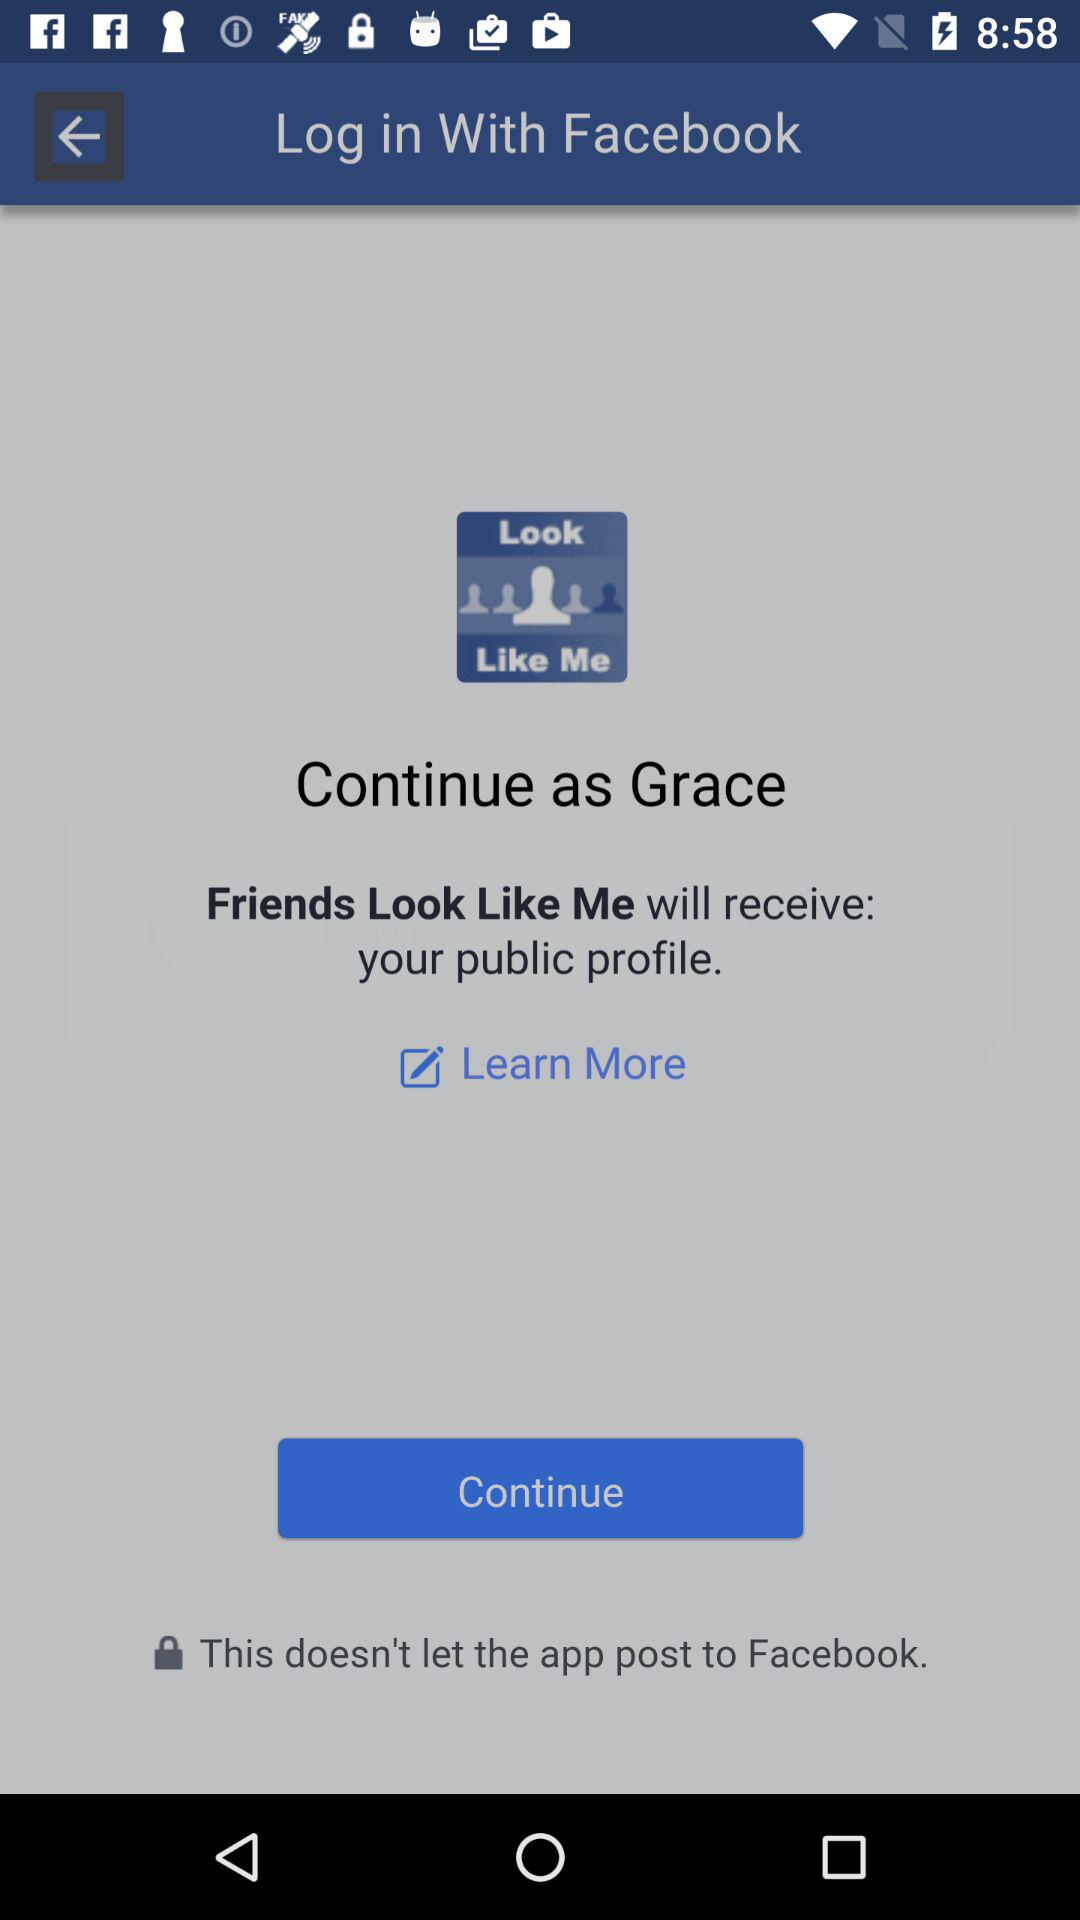What application will receive a public profile? The application is "Friends Look Like Me". 